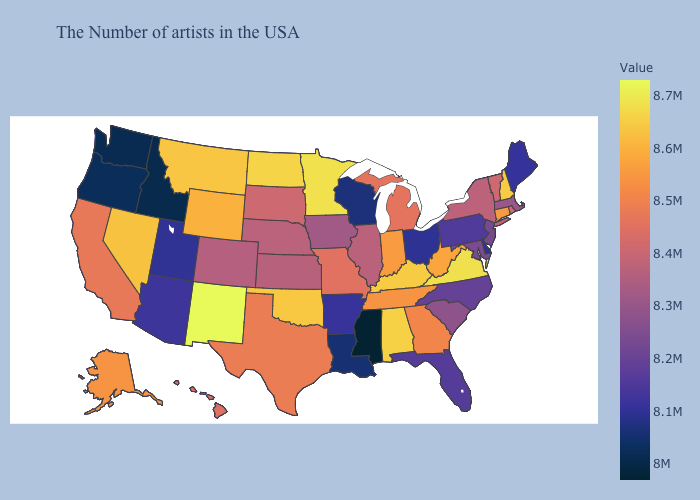Is the legend a continuous bar?
Short answer required. Yes. Does Georgia have a higher value than Oregon?
Give a very brief answer. Yes. Does Maine have the lowest value in the Northeast?
Write a very short answer. Yes. Does the map have missing data?
Be succinct. No. Among the states that border Alabama , does Tennessee have the highest value?
Give a very brief answer. Yes. 